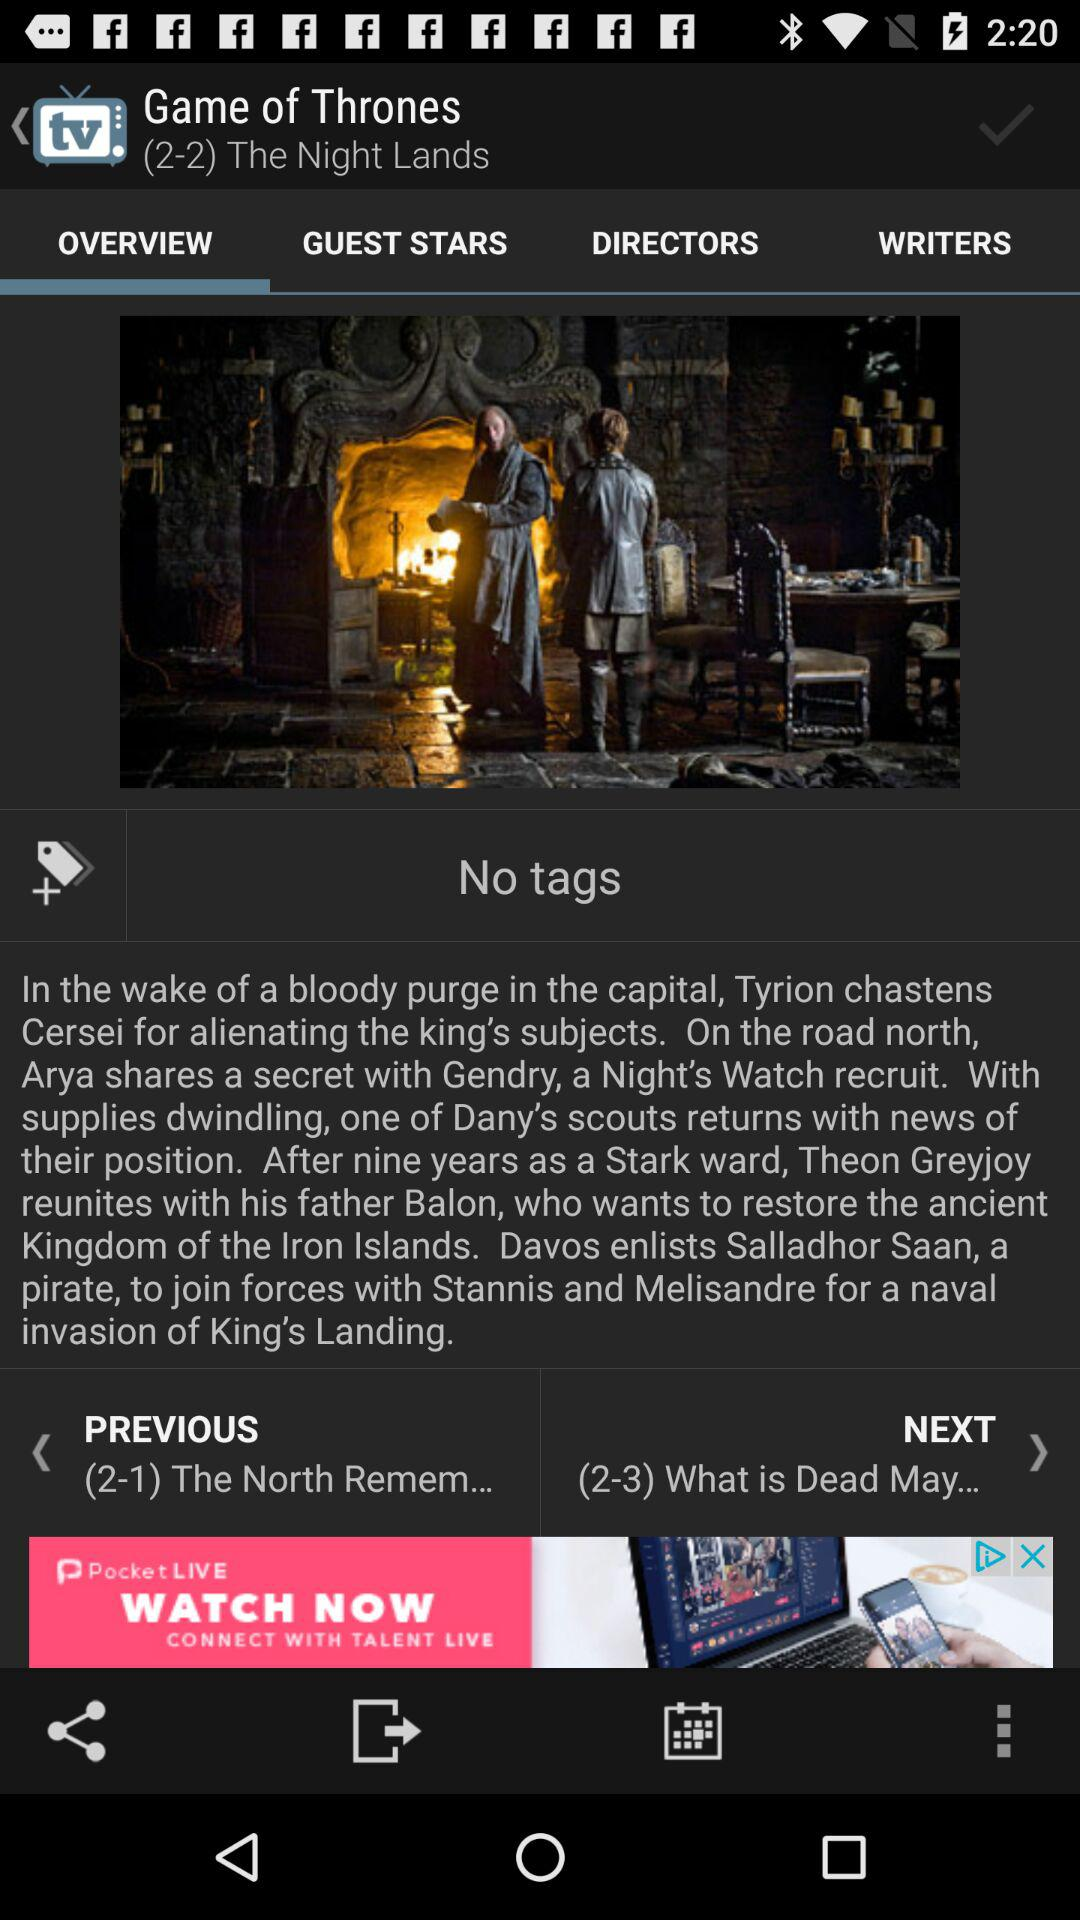What is the series name? The series name is "Game of Thrones". 